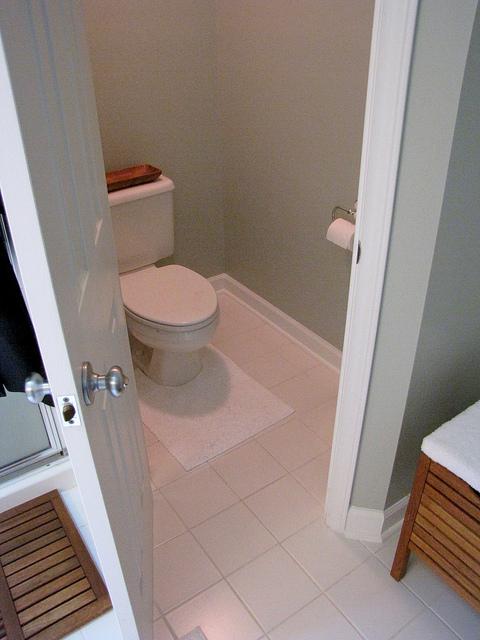Can you lock the door?
Short answer required. Yes. What color is dominant?
Answer briefly. White. Is the toilet paper under or over?
Give a very brief answer. Over. 